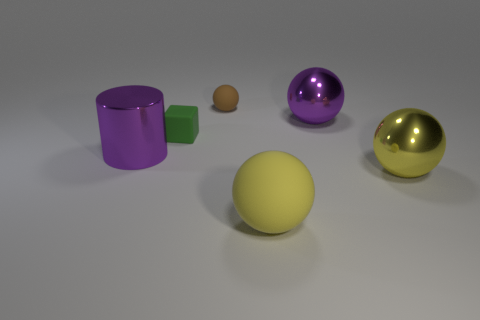Subtract all purple metallic balls. How many balls are left? 3 Subtract 1 blocks. How many blocks are left? 0 Subtract all gray cylinders. How many yellow balls are left? 2 Subtract all purple spheres. How many spheres are left? 3 Add 1 brown cubes. How many objects exist? 7 Subtract all cubes. How many objects are left? 5 Subtract all big green matte balls. Subtract all tiny green rubber objects. How many objects are left? 5 Add 3 blocks. How many blocks are left? 4 Add 1 small red rubber cylinders. How many small red rubber cylinders exist? 1 Subtract 1 green cubes. How many objects are left? 5 